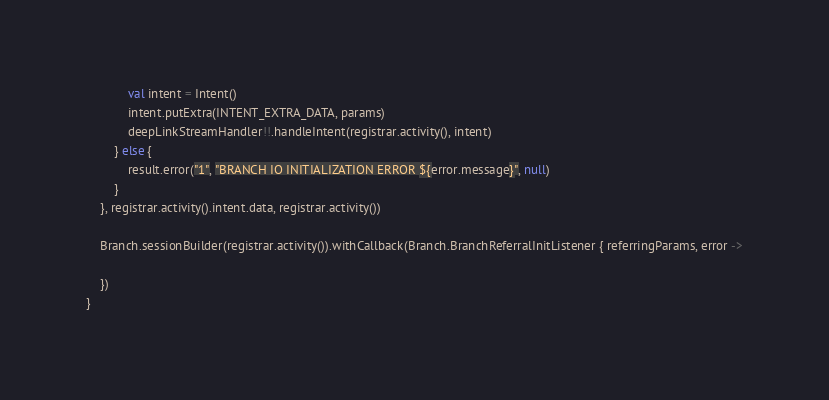Convert code to text. <code><loc_0><loc_0><loc_500><loc_500><_Kotlin_>            val intent = Intent()
            intent.putExtra(INTENT_EXTRA_DATA, params)
            deepLinkStreamHandler!!.handleIntent(registrar.activity(), intent)
        } else {
            result.error("1", "BRANCH IO INITIALIZATION ERROR ${error.message}", null)
        }
    }, registrar.activity().intent.data, registrar.activity())

    Branch.sessionBuilder(registrar.activity()).withCallback(Branch.BranchReferralInitListener { referringParams, error ->

    })
}</code> 